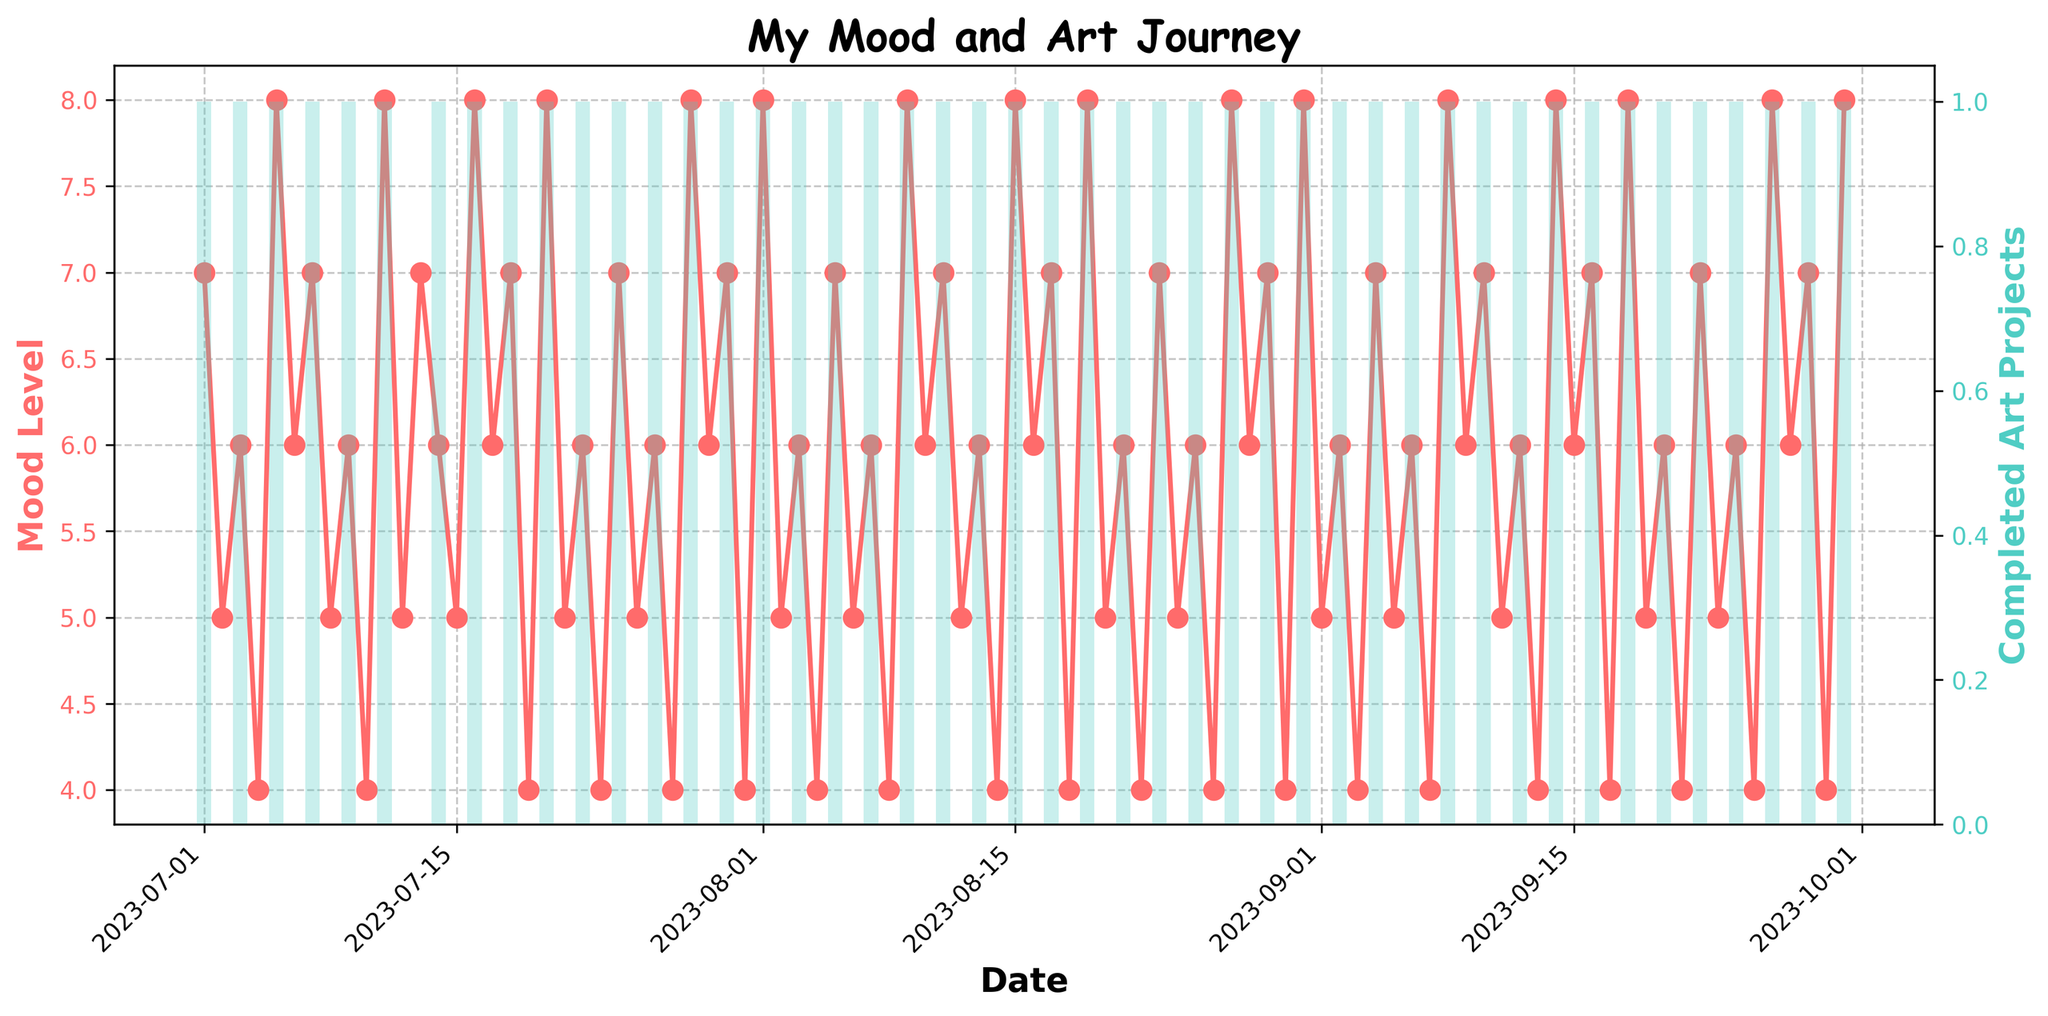What is the title of the plot? The title of the plot is typically found at the top of the figure. Here, it reads "My Mood and Art Journey".
Answer: My Mood and Art Journey What color is used to represent the Mood Level line? The color used to represent the Mood Level line is typically indicated by the line itself. In this figure, it is drawn in a shade of red.
Answer: Red How does the mood level on 2023-07-05 compare to the mood level on 2023-07-04? To compare the mood levels, locate the dates 2023-07-05 and 2023-07-04 on the x-axis and refer to the corresponding mood levels on the y-axis. On 2023-07-05 the mood level is 8, and on 2023-07-04 it is 4. 8 is higher than 4.
Answer: Higher On which days did you complete art projects? Days with completed art projects are represented by bars. Here, the bars are on the following days: 2023-07-01, 2023-07-03, 2023-07-05, etc.
Answer: Days with bars, such as 2023-07-01, 2023-07-03, 2023-07-05, etc What is the trend in mood levels when art projects are completed vs. when they are not? To see the trend, compare the mood levels on days where art is completed (tall bars) vs. days it is not (short or no bars). Generally, mood levels are 7-8 on days with completed projects and around 4-6 on days without.
Answer: Higher mood levels on days with completed projects By how much did the mood level change from 2023-09-15 to 2023-09-16? Check the mood levels on 2023-09-15 (which is 6) and 2023-09-16 (which is 7) and take the difference: 7 - 6 = 1.
Answer: 1 What's the average mood level in the first week of July? Add the mood levels from 2023-07-01 to 2023-07-07: 7+5+6+4+8+6+7 = 43. Divide by 7 days. 43 / 7 = 6.14 (approx).
Answer: 6.14 Do more art projects get completed on weekends or weekdays? Examine the frequency of bars (completed art projects) over the weekends and weekdays in the plot. Generally, the pattern holds more for weekdays.
Answer: Weekdays Which month had the highest average mood level? Calculate the average mood level for each month: July (sum: 195/31 days), August (sum: 194/31 days), September (sum: 185/30 days). July's average is highest.
Answer: July What is the longest streak of consecutive days with completed art projects? Look for the longest sequence of consecutive days with bars representing completed art projects. There are multiple 1-day streaks, but no multi-day consecutive streaks.
Answer: 1 day 